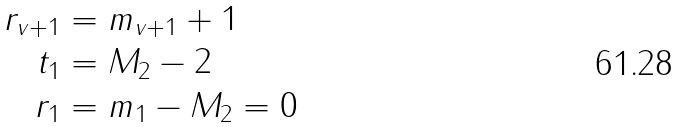Convert formula to latex. <formula><loc_0><loc_0><loc_500><loc_500>r _ { v + 1 } & = m _ { v + 1 } + 1 \\ t _ { 1 } & = M _ { 2 } - 2 \\ r _ { 1 } & = m _ { 1 } - M _ { 2 } = 0</formula> 